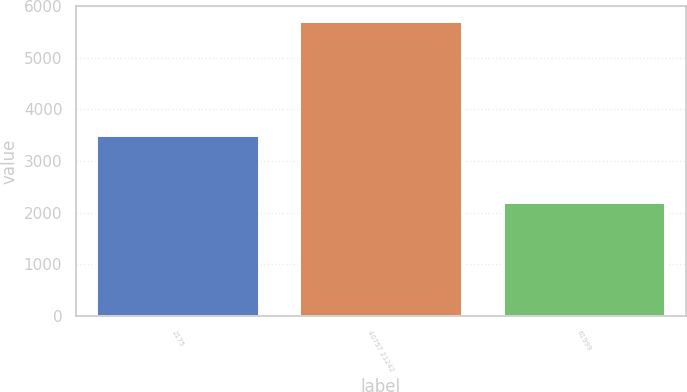Convert chart to OTSL. <chart><loc_0><loc_0><loc_500><loc_500><bar_chart><fcel>2175<fcel>40757 21242<fcel>61999<nl><fcel>3509<fcel>5719<fcel>2210<nl></chart> 